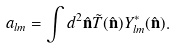<formula> <loc_0><loc_0><loc_500><loc_500>a _ { l m } = \int d ^ { 2 } \hat { \mathbf n } \tilde { T } ( \hat { \mathbf n } ) Y ^ { * } _ { l m } ( \hat { \mathbf n } ) .</formula> 